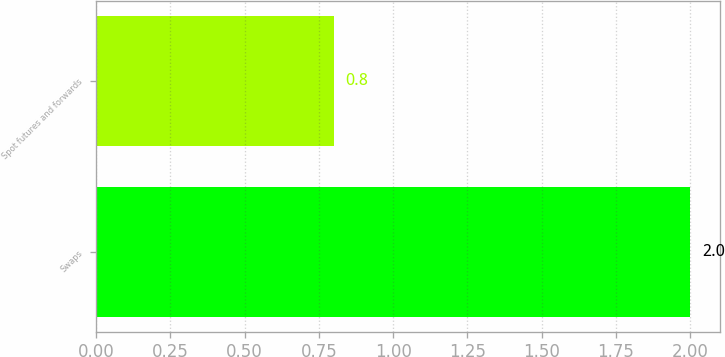Convert chart to OTSL. <chart><loc_0><loc_0><loc_500><loc_500><bar_chart><fcel>Swaps<fcel>Spot futures and forwards<nl><fcel>2<fcel>0.8<nl></chart> 